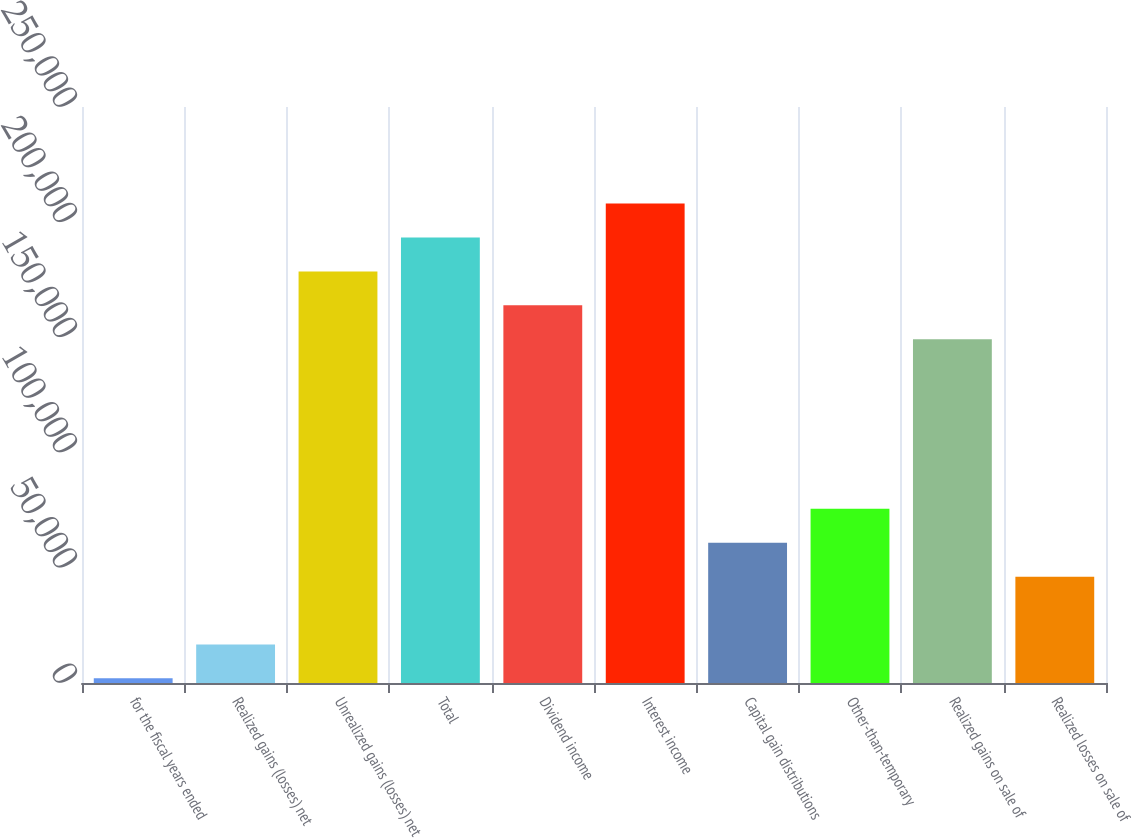<chart> <loc_0><loc_0><loc_500><loc_500><bar_chart><fcel>for the fiscal years ended<fcel>Realized gains (losses) net<fcel>Unrealized gains (losses) net<fcel>Total<fcel>Dividend income<fcel>Interest income<fcel>Capital gain distributions<fcel>Other-than-temporary<fcel>Realized gains on sale of<fcel>Realized losses on sale of<nl><fcel>2008<fcel>16726.5<fcel>178630<fcel>193348<fcel>163912<fcel>208067<fcel>60882<fcel>75600.5<fcel>149193<fcel>46163.5<nl></chart> 